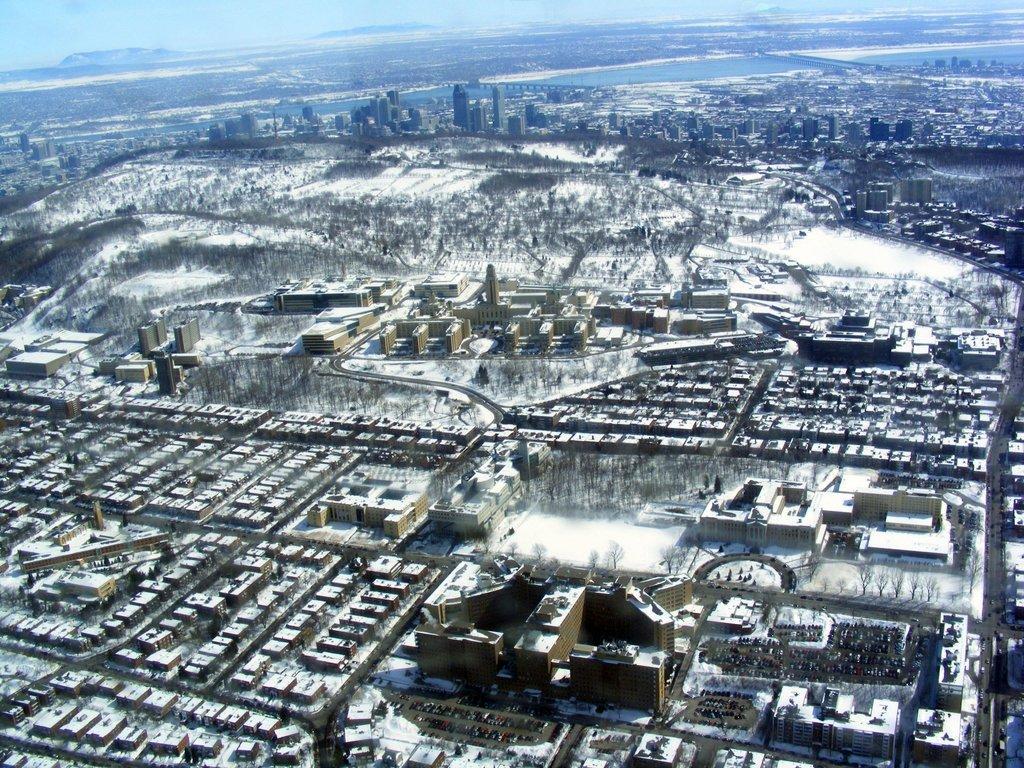Can you describe this image briefly? In this picture we can observe buildings. There is some snow. We can observe some water in the background. There are hills here. 